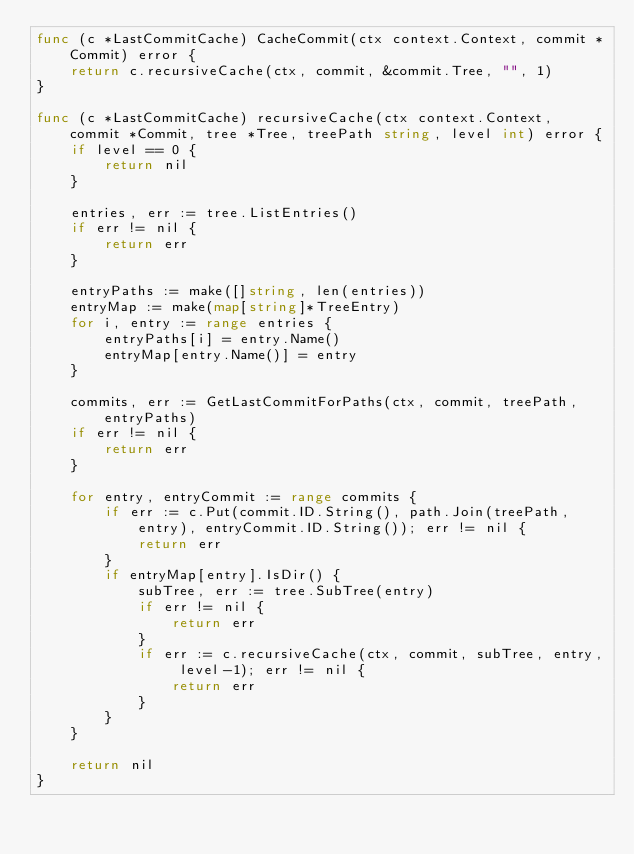Convert code to text. <code><loc_0><loc_0><loc_500><loc_500><_Go_>func (c *LastCommitCache) CacheCommit(ctx context.Context, commit *Commit) error {
	return c.recursiveCache(ctx, commit, &commit.Tree, "", 1)
}

func (c *LastCommitCache) recursiveCache(ctx context.Context, commit *Commit, tree *Tree, treePath string, level int) error {
	if level == 0 {
		return nil
	}

	entries, err := tree.ListEntries()
	if err != nil {
		return err
	}

	entryPaths := make([]string, len(entries))
	entryMap := make(map[string]*TreeEntry)
	for i, entry := range entries {
		entryPaths[i] = entry.Name()
		entryMap[entry.Name()] = entry
	}

	commits, err := GetLastCommitForPaths(ctx, commit, treePath, entryPaths)
	if err != nil {
		return err
	}

	for entry, entryCommit := range commits {
		if err := c.Put(commit.ID.String(), path.Join(treePath, entry), entryCommit.ID.String()); err != nil {
			return err
		}
		if entryMap[entry].IsDir() {
			subTree, err := tree.SubTree(entry)
			if err != nil {
				return err
			}
			if err := c.recursiveCache(ctx, commit, subTree, entry, level-1); err != nil {
				return err
			}
		}
	}

	return nil
}
</code> 